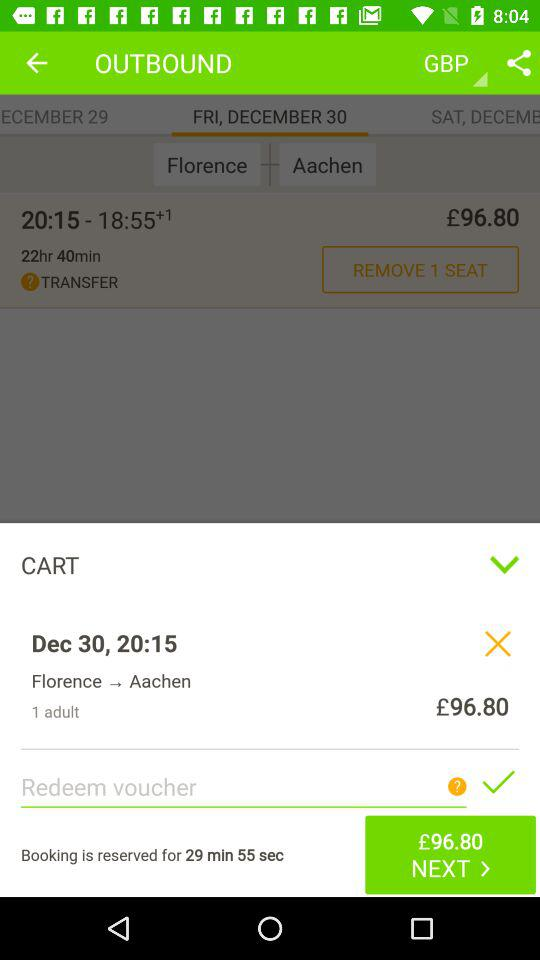What is the given date? The given date is Friday, December 30. 